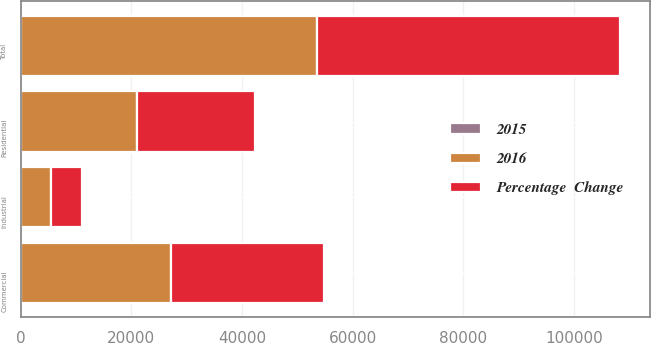<chart> <loc_0><loc_0><loc_500><loc_500><stacked_bar_chart><ecel><fcel>Residential<fcel>Commercial<fcel>Industrial<fcel>Total<nl><fcel>2016<fcel>21002<fcel>27206<fcel>5434<fcel>53642<nl><fcel>Percentage  Change<fcel>21441<fcel>27598<fcel>5577<fcel>54616<nl><fcel>2015<fcel>2<fcel>1.4<fcel>2.6<fcel>1.8<nl></chart> 